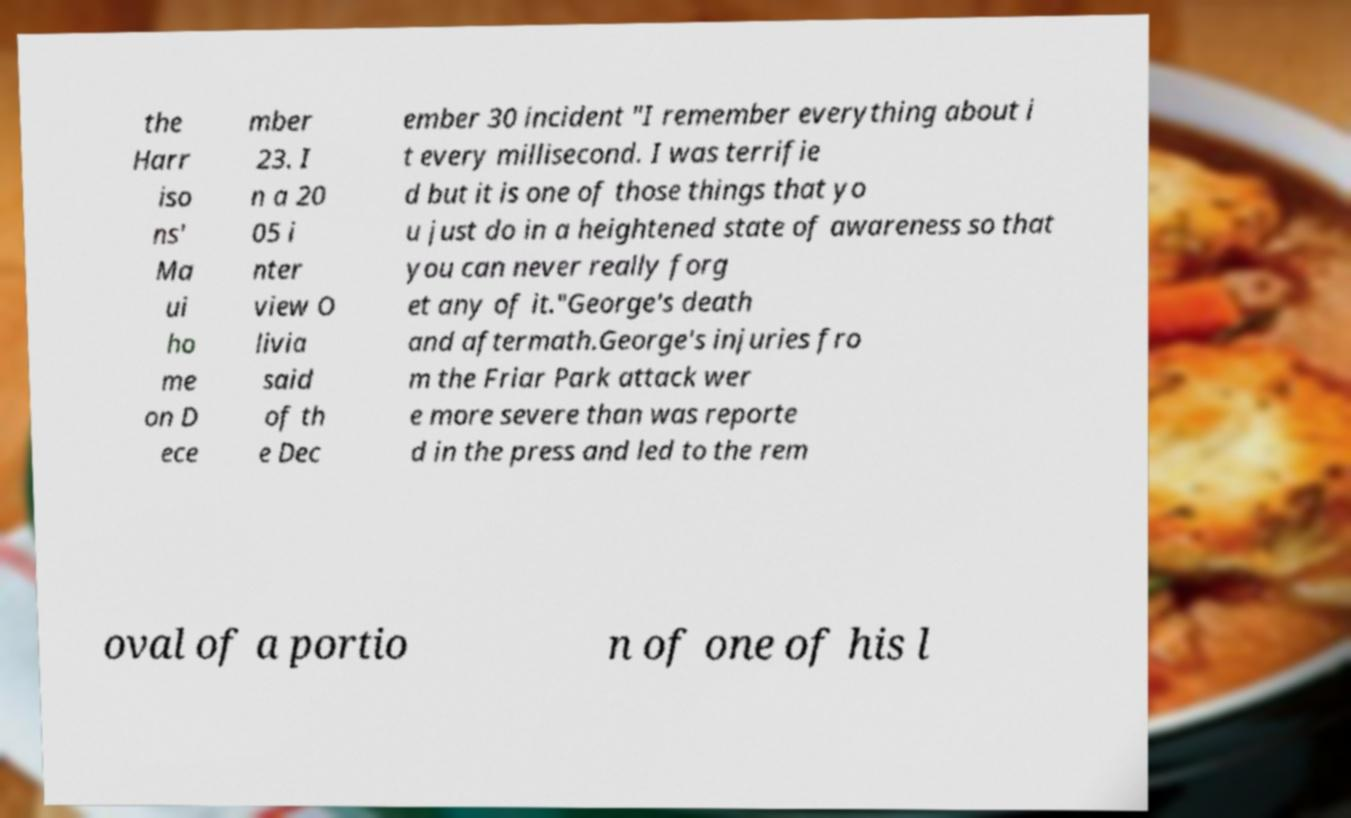I need the written content from this picture converted into text. Can you do that? the Harr iso ns' Ma ui ho me on D ece mber 23. I n a 20 05 i nter view O livia said of th e Dec ember 30 incident "I remember everything about i t every millisecond. I was terrifie d but it is one of those things that yo u just do in a heightened state of awareness so that you can never really forg et any of it."George's death and aftermath.George's injuries fro m the Friar Park attack wer e more severe than was reporte d in the press and led to the rem oval of a portio n of one of his l 